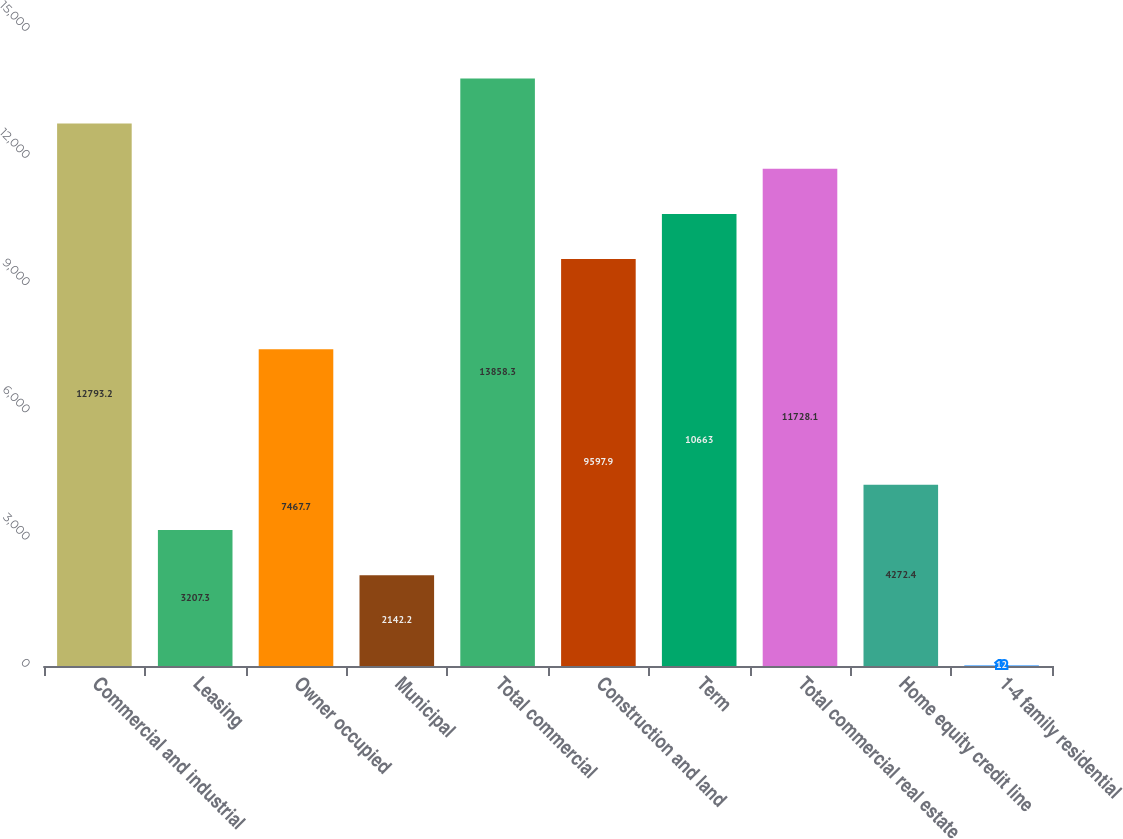Convert chart. <chart><loc_0><loc_0><loc_500><loc_500><bar_chart><fcel>Commercial and industrial<fcel>Leasing<fcel>Owner occupied<fcel>Municipal<fcel>Total commercial<fcel>Construction and land<fcel>Term<fcel>Total commercial real estate<fcel>Home equity credit line<fcel>1-4 family residential<nl><fcel>12793.2<fcel>3207.3<fcel>7467.7<fcel>2142.2<fcel>13858.3<fcel>9597.9<fcel>10663<fcel>11728.1<fcel>4272.4<fcel>12<nl></chart> 